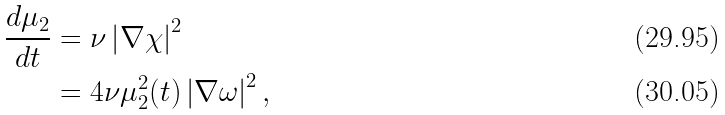<formula> <loc_0><loc_0><loc_500><loc_500>\frac { d \mu _ { 2 } } { d t } & = \nu \left | \nabla \chi \right | ^ { 2 } \\ & = 4 \nu \mu _ { 2 } ^ { 2 } ( t ) \left | \nabla \omega \right | ^ { 2 } ,</formula> 